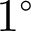<formula> <loc_0><loc_0><loc_500><loc_500>1 ^ { \circ }</formula> 